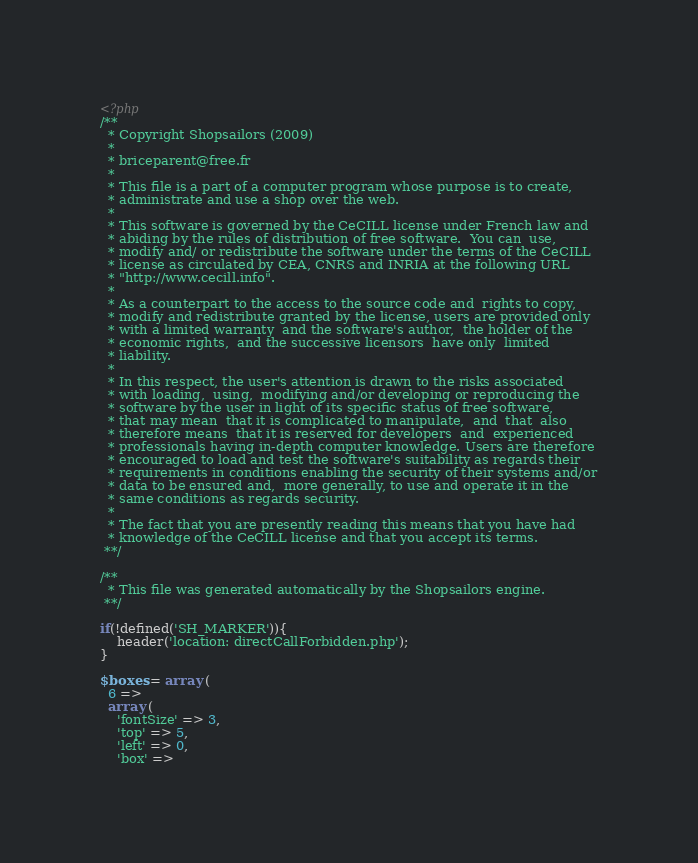<code> <loc_0><loc_0><loc_500><loc_500><_PHP_><?php
/**
  * Copyright Shopsailors (2009)
  *
  * briceparent@free.fr
  *
  * This file is a part of a computer program whose purpose is to create,
  * administrate and use a shop over the web.
  *
  * This software is governed by the CeCILL license under French law and
  * abiding by the rules of distribution of free software.  You can  use,
  * modify and/ or redistribute the software under the terms of the CeCILL
  * license as circulated by CEA, CNRS and INRIA at the following URL
  * "http://www.cecill.info".
  *
  * As a counterpart to the access to the source code and  rights to copy,
  * modify and redistribute granted by the license, users are provided only
  * with a limited warranty  and the software's author,  the holder of the
  * economic rights,  and the successive licensors  have only  limited
  * liability.
  *
  * In this respect, the user's attention is drawn to the risks associated
  * with loading,  using,  modifying and/or developing or reproducing the
  * software by the user in light of its specific status of free software,
  * that may mean  that it is complicated to manipulate,  and  that  also
  * therefore means  that it is reserved for developers  and  experienced
  * professionals having in-depth computer knowledge. Users are therefore
  * encouraged to load and test the software's suitability as regards their
  * requirements in conditions enabling the security of their systems and/or
  * data to be ensured and,  more generally, to use and operate it in the
  * same conditions as regards security.
  *
  * The fact that you are presently reading this means that you have had
  * knowledge of the CeCILL license and that you accept its terms.
 **/

/**
  * This file was generated automatically by the Shopsailors engine.
 **/

if(!defined('SH_MARKER')){
    header('location: directCallForbidden.php');
}

$boxes = array (
  6 => 
  array (
    'fontSize' => 3,
    'top' => 5,
    'left' => 0,
    'box' => </code> 